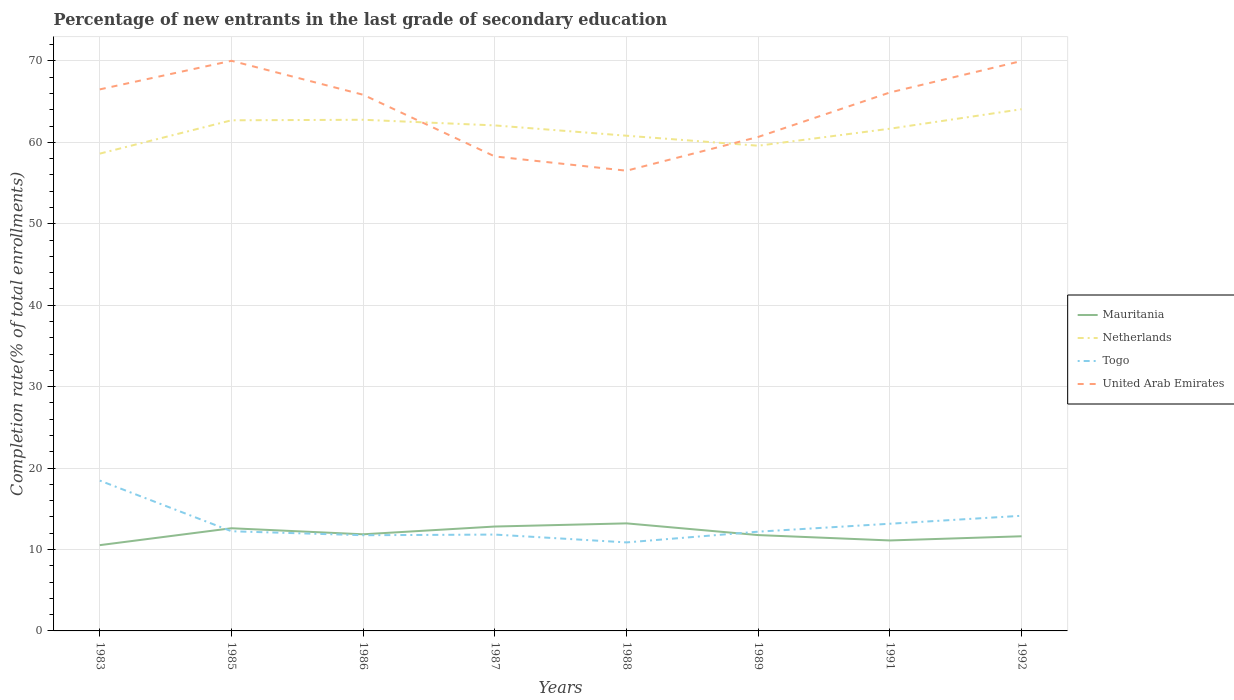Across all years, what is the maximum percentage of new entrants in Togo?
Provide a short and direct response. 10.87. What is the total percentage of new entrants in Netherlands in the graph?
Your answer should be compact. 3.19. What is the difference between the highest and the second highest percentage of new entrants in Netherlands?
Offer a terse response. 5.45. Is the percentage of new entrants in United Arab Emirates strictly greater than the percentage of new entrants in Togo over the years?
Ensure brevity in your answer.  No. Are the values on the major ticks of Y-axis written in scientific E-notation?
Your response must be concise. No. Does the graph contain any zero values?
Your answer should be very brief. No. Where does the legend appear in the graph?
Your answer should be compact. Center right. What is the title of the graph?
Provide a succinct answer. Percentage of new entrants in the last grade of secondary education. What is the label or title of the Y-axis?
Ensure brevity in your answer.  Completion rate(% of total enrollments). What is the Completion rate(% of total enrollments) in Mauritania in 1983?
Provide a short and direct response. 10.53. What is the Completion rate(% of total enrollments) in Netherlands in 1983?
Your response must be concise. 58.61. What is the Completion rate(% of total enrollments) in Togo in 1983?
Your answer should be compact. 18.46. What is the Completion rate(% of total enrollments) of United Arab Emirates in 1983?
Provide a short and direct response. 66.5. What is the Completion rate(% of total enrollments) of Mauritania in 1985?
Offer a very short reply. 12.61. What is the Completion rate(% of total enrollments) of Netherlands in 1985?
Provide a succinct answer. 62.7. What is the Completion rate(% of total enrollments) of Togo in 1985?
Offer a very short reply. 12.24. What is the Completion rate(% of total enrollments) in United Arab Emirates in 1985?
Give a very brief answer. 70.01. What is the Completion rate(% of total enrollments) in Mauritania in 1986?
Make the answer very short. 11.87. What is the Completion rate(% of total enrollments) of Netherlands in 1986?
Keep it short and to the point. 62.77. What is the Completion rate(% of total enrollments) in Togo in 1986?
Your answer should be very brief. 11.75. What is the Completion rate(% of total enrollments) in United Arab Emirates in 1986?
Provide a short and direct response. 65.84. What is the Completion rate(% of total enrollments) of Mauritania in 1987?
Give a very brief answer. 12.82. What is the Completion rate(% of total enrollments) in Netherlands in 1987?
Your answer should be very brief. 62.07. What is the Completion rate(% of total enrollments) in Togo in 1987?
Provide a succinct answer. 11.83. What is the Completion rate(% of total enrollments) of United Arab Emirates in 1987?
Your answer should be compact. 58.26. What is the Completion rate(% of total enrollments) in Mauritania in 1988?
Make the answer very short. 13.21. What is the Completion rate(% of total enrollments) of Netherlands in 1988?
Provide a succinct answer. 60.81. What is the Completion rate(% of total enrollments) of Togo in 1988?
Your answer should be compact. 10.87. What is the Completion rate(% of total enrollments) in United Arab Emirates in 1988?
Ensure brevity in your answer.  56.51. What is the Completion rate(% of total enrollments) in Mauritania in 1989?
Offer a very short reply. 11.77. What is the Completion rate(% of total enrollments) of Netherlands in 1989?
Ensure brevity in your answer.  59.58. What is the Completion rate(% of total enrollments) in Togo in 1989?
Offer a terse response. 12.19. What is the Completion rate(% of total enrollments) in United Arab Emirates in 1989?
Provide a succinct answer. 60.66. What is the Completion rate(% of total enrollments) in Mauritania in 1991?
Your answer should be very brief. 11.11. What is the Completion rate(% of total enrollments) of Netherlands in 1991?
Keep it short and to the point. 61.67. What is the Completion rate(% of total enrollments) of Togo in 1991?
Make the answer very short. 13.16. What is the Completion rate(% of total enrollments) in United Arab Emirates in 1991?
Offer a very short reply. 66.12. What is the Completion rate(% of total enrollments) in Mauritania in 1992?
Provide a succinct answer. 11.62. What is the Completion rate(% of total enrollments) of Netherlands in 1992?
Offer a very short reply. 64.06. What is the Completion rate(% of total enrollments) of Togo in 1992?
Offer a very short reply. 14.14. What is the Completion rate(% of total enrollments) in United Arab Emirates in 1992?
Ensure brevity in your answer.  69.99. Across all years, what is the maximum Completion rate(% of total enrollments) of Mauritania?
Provide a short and direct response. 13.21. Across all years, what is the maximum Completion rate(% of total enrollments) of Netherlands?
Provide a short and direct response. 64.06. Across all years, what is the maximum Completion rate(% of total enrollments) of Togo?
Your answer should be compact. 18.46. Across all years, what is the maximum Completion rate(% of total enrollments) of United Arab Emirates?
Your response must be concise. 70.01. Across all years, what is the minimum Completion rate(% of total enrollments) of Mauritania?
Make the answer very short. 10.53. Across all years, what is the minimum Completion rate(% of total enrollments) in Netherlands?
Your answer should be very brief. 58.61. Across all years, what is the minimum Completion rate(% of total enrollments) of Togo?
Your answer should be compact. 10.87. Across all years, what is the minimum Completion rate(% of total enrollments) in United Arab Emirates?
Provide a short and direct response. 56.51. What is the total Completion rate(% of total enrollments) in Mauritania in the graph?
Give a very brief answer. 95.53. What is the total Completion rate(% of total enrollments) of Netherlands in the graph?
Provide a succinct answer. 492.28. What is the total Completion rate(% of total enrollments) in Togo in the graph?
Offer a terse response. 104.64. What is the total Completion rate(% of total enrollments) in United Arab Emirates in the graph?
Offer a terse response. 513.89. What is the difference between the Completion rate(% of total enrollments) of Mauritania in 1983 and that in 1985?
Offer a very short reply. -2.08. What is the difference between the Completion rate(% of total enrollments) of Netherlands in 1983 and that in 1985?
Offer a terse response. -4.09. What is the difference between the Completion rate(% of total enrollments) in Togo in 1983 and that in 1985?
Your answer should be very brief. 6.22. What is the difference between the Completion rate(% of total enrollments) in United Arab Emirates in 1983 and that in 1985?
Your answer should be very brief. -3.51. What is the difference between the Completion rate(% of total enrollments) in Mauritania in 1983 and that in 1986?
Your answer should be compact. -1.33. What is the difference between the Completion rate(% of total enrollments) in Netherlands in 1983 and that in 1986?
Provide a short and direct response. -4.16. What is the difference between the Completion rate(% of total enrollments) in Togo in 1983 and that in 1986?
Give a very brief answer. 6.71. What is the difference between the Completion rate(% of total enrollments) in United Arab Emirates in 1983 and that in 1986?
Your response must be concise. 0.66. What is the difference between the Completion rate(% of total enrollments) of Mauritania in 1983 and that in 1987?
Your answer should be compact. -2.29. What is the difference between the Completion rate(% of total enrollments) in Netherlands in 1983 and that in 1987?
Provide a short and direct response. -3.46. What is the difference between the Completion rate(% of total enrollments) of Togo in 1983 and that in 1987?
Give a very brief answer. 6.63. What is the difference between the Completion rate(% of total enrollments) of United Arab Emirates in 1983 and that in 1987?
Your answer should be compact. 8.24. What is the difference between the Completion rate(% of total enrollments) in Mauritania in 1983 and that in 1988?
Your answer should be compact. -2.68. What is the difference between the Completion rate(% of total enrollments) of Netherlands in 1983 and that in 1988?
Provide a short and direct response. -2.2. What is the difference between the Completion rate(% of total enrollments) of Togo in 1983 and that in 1988?
Provide a succinct answer. 7.59. What is the difference between the Completion rate(% of total enrollments) in United Arab Emirates in 1983 and that in 1988?
Ensure brevity in your answer.  9.99. What is the difference between the Completion rate(% of total enrollments) of Mauritania in 1983 and that in 1989?
Keep it short and to the point. -1.24. What is the difference between the Completion rate(% of total enrollments) in Netherlands in 1983 and that in 1989?
Ensure brevity in your answer.  -0.97. What is the difference between the Completion rate(% of total enrollments) in Togo in 1983 and that in 1989?
Give a very brief answer. 6.27. What is the difference between the Completion rate(% of total enrollments) in United Arab Emirates in 1983 and that in 1989?
Your answer should be very brief. 5.84. What is the difference between the Completion rate(% of total enrollments) of Mauritania in 1983 and that in 1991?
Your answer should be compact. -0.58. What is the difference between the Completion rate(% of total enrollments) in Netherlands in 1983 and that in 1991?
Provide a succinct answer. -3.06. What is the difference between the Completion rate(% of total enrollments) in Togo in 1983 and that in 1991?
Provide a succinct answer. 5.3. What is the difference between the Completion rate(% of total enrollments) in United Arab Emirates in 1983 and that in 1991?
Your answer should be very brief. 0.38. What is the difference between the Completion rate(% of total enrollments) in Mauritania in 1983 and that in 1992?
Keep it short and to the point. -1.09. What is the difference between the Completion rate(% of total enrollments) of Netherlands in 1983 and that in 1992?
Offer a very short reply. -5.45. What is the difference between the Completion rate(% of total enrollments) of Togo in 1983 and that in 1992?
Give a very brief answer. 4.32. What is the difference between the Completion rate(% of total enrollments) in United Arab Emirates in 1983 and that in 1992?
Keep it short and to the point. -3.49. What is the difference between the Completion rate(% of total enrollments) in Mauritania in 1985 and that in 1986?
Give a very brief answer. 0.74. What is the difference between the Completion rate(% of total enrollments) in Netherlands in 1985 and that in 1986?
Offer a terse response. -0.07. What is the difference between the Completion rate(% of total enrollments) of Togo in 1985 and that in 1986?
Give a very brief answer. 0.49. What is the difference between the Completion rate(% of total enrollments) in United Arab Emirates in 1985 and that in 1986?
Provide a short and direct response. 4.17. What is the difference between the Completion rate(% of total enrollments) of Mauritania in 1985 and that in 1987?
Your response must be concise. -0.21. What is the difference between the Completion rate(% of total enrollments) of Netherlands in 1985 and that in 1987?
Your answer should be very brief. 0.63. What is the difference between the Completion rate(% of total enrollments) of Togo in 1985 and that in 1987?
Give a very brief answer. 0.41. What is the difference between the Completion rate(% of total enrollments) of United Arab Emirates in 1985 and that in 1987?
Give a very brief answer. 11.75. What is the difference between the Completion rate(% of total enrollments) in Mauritania in 1985 and that in 1988?
Your response must be concise. -0.6. What is the difference between the Completion rate(% of total enrollments) of Netherlands in 1985 and that in 1988?
Offer a terse response. 1.89. What is the difference between the Completion rate(% of total enrollments) of Togo in 1985 and that in 1988?
Give a very brief answer. 1.37. What is the difference between the Completion rate(% of total enrollments) of United Arab Emirates in 1985 and that in 1988?
Your answer should be very brief. 13.5. What is the difference between the Completion rate(% of total enrollments) of Mauritania in 1985 and that in 1989?
Provide a short and direct response. 0.84. What is the difference between the Completion rate(% of total enrollments) of Netherlands in 1985 and that in 1989?
Make the answer very short. 3.12. What is the difference between the Completion rate(% of total enrollments) in Togo in 1985 and that in 1989?
Your answer should be compact. 0.05. What is the difference between the Completion rate(% of total enrollments) in United Arab Emirates in 1985 and that in 1989?
Offer a terse response. 9.35. What is the difference between the Completion rate(% of total enrollments) in Mauritania in 1985 and that in 1991?
Give a very brief answer. 1.5. What is the difference between the Completion rate(% of total enrollments) in Netherlands in 1985 and that in 1991?
Offer a very short reply. 1.03. What is the difference between the Completion rate(% of total enrollments) in Togo in 1985 and that in 1991?
Provide a succinct answer. -0.92. What is the difference between the Completion rate(% of total enrollments) in United Arab Emirates in 1985 and that in 1991?
Offer a terse response. 3.89. What is the difference between the Completion rate(% of total enrollments) in Mauritania in 1985 and that in 1992?
Keep it short and to the point. 0.99. What is the difference between the Completion rate(% of total enrollments) in Netherlands in 1985 and that in 1992?
Your answer should be very brief. -1.36. What is the difference between the Completion rate(% of total enrollments) of Togo in 1985 and that in 1992?
Your answer should be compact. -1.9. What is the difference between the Completion rate(% of total enrollments) of United Arab Emirates in 1985 and that in 1992?
Give a very brief answer. 0.02. What is the difference between the Completion rate(% of total enrollments) of Mauritania in 1986 and that in 1987?
Your answer should be very brief. -0.95. What is the difference between the Completion rate(% of total enrollments) in Netherlands in 1986 and that in 1987?
Ensure brevity in your answer.  0.69. What is the difference between the Completion rate(% of total enrollments) of Togo in 1986 and that in 1987?
Your answer should be compact. -0.08. What is the difference between the Completion rate(% of total enrollments) in United Arab Emirates in 1986 and that in 1987?
Provide a succinct answer. 7.58. What is the difference between the Completion rate(% of total enrollments) in Mauritania in 1986 and that in 1988?
Provide a short and direct response. -1.34. What is the difference between the Completion rate(% of total enrollments) of Netherlands in 1986 and that in 1988?
Provide a succinct answer. 1.96. What is the difference between the Completion rate(% of total enrollments) of Togo in 1986 and that in 1988?
Offer a very short reply. 0.88. What is the difference between the Completion rate(% of total enrollments) in United Arab Emirates in 1986 and that in 1988?
Your response must be concise. 9.33. What is the difference between the Completion rate(% of total enrollments) in Mauritania in 1986 and that in 1989?
Your answer should be very brief. 0.1. What is the difference between the Completion rate(% of total enrollments) of Netherlands in 1986 and that in 1989?
Your response must be concise. 3.19. What is the difference between the Completion rate(% of total enrollments) in Togo in 1986 and that in 1989?
Your answer should be very brief. -0.44. What is the difference between the Completion rate(% of total enrollments) of United Arab Emirates in 1986 and that in 1989?
Provide a short and direct response. 5.18. What is the difference between the Completion rate(% of total enrollments) in Mauritania in 1986 and that in 1991?
Offer a very short reply. 0.76. What is the difference between the Completion rate(% of total enrollments) in Netherlands in 1986 and that in 1991?
Your answer should be compact. 1.1. What is the difference between the Completion rate(% of total enrollments) of Togo in 1986 and that in 1991?
Offer a very short reply. -1.41. What is the difference between the Completion rate(% of total enrollments) in United Arab Emirates in 1986 and that in 1991?
Your answer should be compact. -0.28. What is the difference between the Completion rate(% of total enrollments) of Mauritania in 1986 and that in 1992?
Your answer should be very brief. 0.24. What is the difference between the Completion rate(% of total enrollments) in Netherlands in 1986 and that in 1992?
Keep it short and to the point. -1.3. What is the difference between the Completion rate(% of total enrollments) of Togo in 1986 and that in 1992?
Make the answer very short. -2.39. What is the difference between the Completion rate(% of total enrollments) in United Arab Emirates in 1986 and that in 1992?
Make the answer very short. -4.15. What is the difference between the Completion rate(% of total enrollments) in Mauritania in 1987 and that in 1988?
Provide a succinct answer. -0.39. What is the difference between the Completion rate(% of total enrollments) in Netherlands in 1987 and that in 1988?
Your answer should be very brief. 1.26. What is the difference between the Completion rate(% of total enrollments) of Togo in 1987 and that in 1988?
Your response must be concise. 0.96. What is the difference between the Completion rate(% of total enrollments) in United Arab Emirates in 1987 and that in 1988?
Offer a very short reply. 1.75. What is the difference between the Completion rate(% of total enrollments) of Mauritania in 1987 and that in 1989?
Provide a succinct answer. 1.05. What is the difference between the Completion rate(% of total enrollments) in Netherlands in 1987 and that in 1989?
Give a very brief answer. 2.49. What is the difference between the Completion rate(% of total enrollments) in Togo in 1987 and that in 1989?
Your response must be concise. -0.36. What is the difference between the Completion rate(% of total enrollments) in United Arab Emirates in 1987 and that in 1989?
Your response must be concise. -2.4. What is the difference between the Completion rate(% of total enrollments) of Mauritania in 1987 and that in 1991?
Your answer should be compact. 1.71. What is the difference between the Completion rate(% of total enrollments) in Netherlands in 1987 and that in 1991?
Your answer should be compact. 0.4. What is the difference between the Completion rate(% of total enrollments) of Togo in 1987 and that in 1991?
Keep it short and to the point. -1.33. What is the difference between the Completion rate(% of total enrollments) of United Arab Emirates in 1987 and that in 1991?
Keep it short and to the point. -7.86. What is the difference between the Completion rate(% of total enrollments) of Mauritania in 1987 and that in 1992?
Make the answer very short. 1.2. What is the difference between the Completion rate(% of total enrollments) in Netherlands in 1987 and that in 1992?
Offer a very short reply. -1.99. What is the difference between the Completion rate(% of total enrollments) of Togo in 1987 and that in 1992?
Keep it short and to the point. -2.31. What is the difference between the Completion rate(% of total enrollments) in United Arab Emirates in 1987 and that in 1992?
Provide a succinct answer. -11.72. What is the difference between the Completion rate(% of total enrollments) in Mauritania in 1988 and that in 1989?
Make the answer very short. 1.44. What is the difference between the Completion rate(% of total enrollments) in Netherlands in 1988 and that in 1989?
Make the answer very short. 1.23. What is the difference between the Completion rate(% of total enrollments) in Togo in 1988 and that in 1989?
Your response must be concise. -1.32. What is the difference between the Completion rate(% of total enrollments) in United Arab Emirates in 1988 and that in 1989?
Provide a short and direct response. -4.15. What is the difference between the Completion rate(% of total enrollments) of Mauritania in 1988 and that in 1991?
Make the answer very short. 2.1. What is the difference between the Completion rate(% of total enrollments) in Netherlands in 1988 and that in 1991?
Your answer should be compact. -0.86. What is the difference between the Completion rate(% of total enrollments) of Togo in 1988 and that in 1991?
Ensure brevity in your answer.  -2.29. What is the difference between the Completion rate(% of total enrollments) in United Arab Emirates in 1988 and that in 1991?
Provide a succinct answer. -9.61. What is the difference between the Completion rate(% of total enrollments) of Mauritania in 1988 and that in 1992?
Keep it short and to the point. 1.58. What is the difference between the Completion rate(% of total enrollments) of Netherlands in 1988 and that in 1992?
Offer a terse response. -3.25. What is the difference between the Completion rate(% of total enrollments) in Togo in 1988 and that in 1992?
Offer a very short reply. -3.27. What is the difference between the Completion rate(% of total enrollments) of United Arab Emirates in 1988 and that in 1992?
Provide a short and direct response. -13.47. What is the difference between the Completion rate(% of total enrollments) in Mauritania in 1989 and that in 1991?
Your answer should be very brief. 0.66. What is the difference between the Completion rate(% of total enrollments) in Netherlands in 1989 and that in 1991?
Make the answer very short. -2.09. What is the difference between the Completion rate(% of total enrollments) in Togo in 1989 and that in 1991?
Your answer should be compact. -0.97. What is the difference between the Completion rate(% of total enrollments) in United Arab Emirates in 1989 and that in 1991?
Make the answer very short. -5.46. What is the difference between the Completion rate(% of total enrollments) of Mauritania in 1989 and that in 1992?
Offer a terse response. 0.15. What is the difference between the Completion rate(% of total enrollments) in Netherlands in 1989 and that in 1992?
Your answer should be very brief. -4.48. What is the difference between the Completion rate(% of total enrollments) in Togo in 1989 and that in 1992?
Offer a very short reply. -1.95. What is the difference between the Completion rate(% of total enrollments) in United Arab Emirates in 1989 and that in 1992?
Your answer should be compact. -9.33. What is the difference between the Completion rate(% of total enrollments) of Mauritania in 1991 and that in 1992?
Offer a terse response. -0.51. What is the difference between the Completion rate(% of total enrollments) in Netherlands in 1991 and that in 1992?
Ensure brevity in your answer.  -2.39. What is the difference between the Completion rate(% of total enrollments) in Togo in 1991 and that in 1992?
Provide a short and direct response. -0.98. What is the difference between the Completion rate(% of total enrollments) of United Arab Emirates in 1991 and that in 1992?
Your answer should be very brief. -3.87. What is the difference between the Completion rate(% of total enrollments) of Mauritania in 1983 and the Completion rate(% of total enrollments) of Netherlands in 1985?
Your answer should be very brief. -52.17. What is the difference between the Completion rate(% of total enrollments) of Mauritania in 1983 and the Completion rate(% of total enrollments) of Togo in 1985?
Your answer should be very brief. -1.71. What is the difference between the Completion rate(% of total enrollments) of Mauritania in 1983 and the Completion rate(% of total enrollments) of United Arab Emirates in 1985?
Provide a succinct answer. -59.48. What is the difference between the Completion rate(% of total enrollments) of Netherlands in 1983 and the Completion rate(% of total enrollments) of Togo in 1985?
Make the answer very short. 46.37. What is the difference between the Completion rate(% of total enrollments) of Netherlands in 1983 and the Completion rate(% of total enrollments) of United Arab Emirates in 1985?
Your answer should be compact. -11.4. What is the difference between the Completion rate(% of total enrollments) in Togo in 1983 and the Completion rate(% of total enrollments) in United Arab Emirates in 1985?
Your response must be concise. -51.55. What is the difference between the Completion rate(% of total enrollments) in Mauritania in 1983 and the Completion rate(% of total enrollments) in Netherlands in 1986?
Offer a very short reply. -52.24. What is the difference between the Completion rate(% of total enrollments) in Mauritania in 1983 and the Completion rate(% of total enrollments) in Togo in 1986?
Ensure brevity in your answer.  -1.22. What is the difference between the Completion rate(% of total enrollments) of Mauritania in 1983 and the Completion rate(% of total enrollments) of United Arab Emirates in 1986?
Provide a succinct answer. -55.31. What is the difference between the Completion rate(% of total enrollments) in Netherlands in 1983 and the Completion rate(% of total enrollments) in Togo in 1986?
Offer a very short reply. 46.86. What is the difference between the Completion rate(% of total enrollments) in Netherlands in 1983 and the Completion rate(% of total enrollments) in United Arab Emirates in 1986?
Provide a succinct answer. -7.23. What is the difference between the Completion rate(% of total enrollments) in Togo in 1983 and the Completion rate(% of total enrollments) in United Arab Emirates in 1986?
Offer a very short reply. -47.38. What is the difference between the Completion rate(% of total enrollments) in Mauritania in 1983 and the Completion rate(% of total enrollments) in Netherlands in 1987?
Provide a succinct answer. -51.54. What is the difference between the Completion rate(% of total enrollments) in Mauritania in 1983 and the Completion rate(% of total enrollments) in Togo in 1987?
Offer a very short reply. -1.3. What is the difference between the Completion rate(% of total enrollments) of Mauritania in 1983 and the Completion rate(% of total enrollments) of United Arab Emirates in 1987?
Offer a very short reply. -47.73. What is the difference between the Completion rate(% of total enrollments) of Netherlands in 1983 and the Completion rate(% of total enrollments) of Togo in 1987?
Your response must be concise. 46.78. What is the difference between the Completion rate(% of total enrollments) in Netherlands in 1983 and the Completion rate(% of total enrollments) in United Arab Emirates in 1987?
Your answer should be compact. 0.35. What is the difference between the Completion rate(% of total enrollments) of Togo in 1983 and the Completion rate(% of total enrollments) of United Arab Emirates in 1987?
Your response must be concise. -39.8. What is the difference between the Completion rate(% of total enrollments) of Mauritania in 1983 and the Completion rate(% of total enrollments) of Netherlands in 1988?
Make the answer very short. -50.28. What is the difference between the Completion rate(% of total enrollments) of Mauritania in 1983 and the Completion rate(% of total enrollments) of Togo in 1988?
Your answer should be very brief. -0.34. What is the difference between the Completion rate(% of total enrollments) in Mauritania in 1983 and the Completion rate(% of total enrollments) in United Arab Emirates in 1988?
Make the answer very short. -45.98. What is the difference between the Completion rate(% of total enrollments) in Netherlands in 1983 and the Completion rate(% of total enrollments) in Togo in 1988?
Provide a succinct answer. 47.74. What is the difference between the Completion rate(% of total enrollments) in Netherlands in 1983 and the Completion rate(% of total enrollments) in United Arab Emirates in 1988?
Give a very brief answer. 2.1. What is the difference between the Completion rate(% of total enrollments) of Togo in 1983 and the Completion rate(% of total enrollments) of United Arab Emirates in 1988?
Your response must be concise. -38.05. What is the difference between the Completion rate(% of total enrollments) of Mauritania in 1983 and the Completion rate(% of total enrollments) of Netherlands in 1989?
Your answer should be compact. -49.05. What is the difference between the Completion rate(% of total enrollments) in Mauritania in 1983 and the Completion rate(% of total enrollments) in Togo in 1989?
Give a very brief answer. -1.66. What is the difference between the Completion rate(% of total enrollments) in Mauritania in 1983 and the Completion rate(% of total enrollments) in United Arab Emirates in 1989?
Make the answer very short. -50.13. What is the difference between the Completion rate(% of total enrollments) of Netherlands in 1983 and the Completion rate(% of total enrollments) of Togo in 1989?
Offer a terse response. 46.42. What is the difference between the Completion rate(% of total enrollments) in Netherlands in 1983 and the Completion rate(% of total enrollments) in United Arab Emirates in 1989?
Your response must be concise. -2.05. What is the difference between the Completion rate(% of total enrollments) of Togo in 1983 and the Completion rate(% of total enrollments) of United Arab Emirates in 1989?
Ensure brevity in your answer.  -42.2. What is the difference between the Completion rate(% of total enrollments) in Mauritania in 1983 and the Completion rate(% of total enrollments) in Netherlands in 1991?
Your answer should be very brief. -51.14. What is the difference between the Completion rate(% of total enrollments) of Mauritania in 1983 and the Completion rate(% of total enrollments) of Togo in 1991?
Offer a very short reply. -2.63. What is the difference between the Completion rate(% of total enrollments) of Mauritania in 1983 and the Completion rate(% of total enrollments) of United Arab Emirates in 1991?
Offer a very short reply. -55.59. What is the difference between the Completion rate(% of total enrollments) in Netherlands in 1983 and the Completion rate(% of total enrollments) in Togo in 1991?
Your answer should be very brief. 45.45. What is the difference between the Completion rate(% of total enrollments) in Netherlands in 1983 and the Completion rate(% of total enrollments) in United Arab Emirates in 1991?
Provide a succinct answer. -7.51. What is the difference between the Completion rate(% of total enrollments) of Togo in 1983 and the Completion rate(% of total enrollments) of United Arab Emirates in 1991?
Your response must be concise. -47.66. What is the difference between the Completion rate(% of total enrollments) in Mauritania in 1983 and the Completion rate(% of total enrollments) in Netherlands in 1992?
Your answer should be compact. -53.53. What is the difference between the Completion rate(% of total enrollments) in Mauritania in 1983 and the Completion rate(% of total enrollments) in Togo in 1992?
Your response must be concise. -3.61. What is the difference between the Completion rate(% of total enrollments) in Mauritania in 1983 and the Completion rate(% of total enrollments) in United Arab Emirates in 1992?
Provide a succinct answer. -59.45. What is the difference between the Completion rate(% of total enrollments) in Netherlands in 1983 and the Completion rate(% of total enrollments) in Togo in 1992?
Ensure brevity in your answer.  44.47. What is the difference between the Completion rate(% of total enrollments) of Netherlands in 1983 and the Completion rate(% of total enrollments) of United Arab Emirates in 1992?
Your answer should be compact. -11.38. What is the difference between the Completion rate(% of total enrollments) of Togo in 1983 and the Completion rate(% of total enrollments) of United Arab Emirates in 1992?
Your answer should be compact. -51.53. What is the difference between the Completion rate(% of total enrollments) of Mauritania in 1985 and the Completion rate(% of total enrollments) of Netherlands in 1986?
Give a very brief answer. -50.16. What is the difference between the Completion rate(% of total enrollments) of Mauritania in 1985 and the Completion rate(% of total enrollments) of Togo in 1986?
Make the answer very short. 0.86. What is the difference between the Completion rate(% of total enrollments) in Mauritania in 1985 and the Completion rate(% of total enrollments) in United Arab Emirates in 1986?
Your answer should be compact. -53.23. What is the difference between the Completion rate(% of total enrollments) in Netherlands in 1985 and the Completion rate(% of total enrollments) in Togo in 1986?
Your response must be concise. 50.95. What is the difference between the Completion rate(% of total enrollments) in Netherlands in 1985 and the Completion rate(% of total enrollments) in United Arab Emirates in 1986?
Offer a terse response. -3.14. What is the difference between the Completion rate(% of total enrollments) of Togo in 1985 and the Completion rate(% of total enrollments) of United Arab Emirates in 1986?
Keep it short and to the point. -53.6. What is the difference between the Completion rate(% of total enrollments) in Mauritania in 1985 and the Completion rate(% of total enrollments) in Netherlands in 1987?
Your response must be concise. -49.47. What is the difference between the Completion rate(% of total enrollments) in Mauritania in 1985 and the Completion rate(% of total enrollments) in Togo in 1987?
Make the answer very short. 0.78. What is the difference between the Completion rate(% of total enrollments) in Mauritania in 1985 and the Completion rate(% of total enrollments) in United Arab Emirates in 1987?
Your answer should be very brief. -45.65. What is the difference between the Completion rate(% of total enrollments) of Netherlands in 1985 and the Completion rate(% of total enrollments) of Togo in 1987?
Make the answer very short. 50.87. What is the difference between the Completion rate(% of total enrollments) in Netherlands in 1985 and the Completion rate(% of total enrollments) in United Arab Emirates in 1987?
Keep it short and to the point. 4.44. What is the difference between the Completion rate(% of total enrollments) in Togo in 1985 and the Completion rate(% of total enrollments) in United Arab Emirates in 1987?
Make the answer very short. -46.02. What is the difference between the Completion rate(% of total enrollments) of Mauritania in 1985 and the Completion rate(% of total enrollments) of Netherlands in 1988?
Keep it short and to the point. -48.2. What is the difference between the Completion rate(% of total enrollments) in Mauritania in 1985 and the Completion rate(% of total enrollments) in Togo in 1988?
Give a very brief answer. 1.74. What is the difference between the Completion rate(% of total enrollments) of Mauritania in 1985 and the Completion rate(% of total enrollments) of United Arab Emirates in 1988?
Your response must be concise. -43.91. What is the difference between the Completion rate(% of total enrollments) of Netherlands in 1985 and the Completion rate(% of total enrollments) of Togo in 1988?
Provide a succinct answer. 51.83. What is the difference between the Completion rate(% of total enrollments) in Netherlands in 1985 and the Completion rate(% of total enrollments) in United Arab Emirates in 1988?
Provide a succinct answer. 6.19. What is the difference between the Completion rate(% of total enrollments) of Togo in 1985 and the Completion rate(% of total enrollments) of United Arab Emirates in 1988?
Your answer should be very brief. -44.27. What is the difference between the Completion rate(% of total enrollments) in Mauritania in 1985 and the Completion rate(% of total enrollments) in Netherlands in 1989?
Ensure brevity in your answer.  -46.97. What is the difference between the Completion rate(% of total enrollments) in Mauritania in 1985 and the Completion rate(% of total enrollments) in Togo in 1989?
Ensure brevity in your answer.  0.42. What is the difference between the Completion rate(% of total enrollments) in Mauritania in 1985 and the Completion rate(% of total enrollments) in United Arab Emirates in 1989?
Your answer should be compact. -48.05. What is the difference between the Completion rate(% of total enrollments) in Netherlands in 1985 and the Completion rate(% of total enrollments) in Togo in 1989?
Make the answer very short. 50.51. What is the difference between the Completion rate(% of total enrollments) of Netherlands in 1985 and the Completion rate(% of total enrollments) of United Arab Emirates in 1989?
Ensure brevity in your answer.  2.04. What is the difference between the Completion rate(% of total enrollments) in Togo in 1985 and the Completion rate(% of total enrollments) in United Arab Emirates in 1989?
Your answer should be compact. -48.42. What is the difference between the Completion rate(% of total enrollments) in Mauritania in 1985 and the Completion rate(% of total enrollments) in Netherlands in 1991?
Offer a terse response. -49.06. What is the difference between the Completion rate(% of total enrollments) of Mauritania in 1985 and the Completion rate(% of total enrollments) of Togo in 1991?
Give a very brief answer. -0.55. What is the difference between the Completion rate(% of total enrollments) in Mauritania in 1985 and the Completion rate(% of total enrollments) in United Arab Emirates in 1991?
Offer a very short reply. -53.51. What is the difference between the Completion rate(% of total enrollments) of Netherlands in 1985 and the Completion rate(% of total enrollments) of Togo in 1991?
Your answer should be very brief. 49.54. What is the difference between the Completion rate(% of total enrollments) of Netherlands in 1985 and the Completion rate(% of total enrollments) of United Arab Emirates in 1991?
Offer a terse response. -3.42. What is the difference between the Completion rate(% of total enrollments) of Togo in 1985 and the Completion rate(% of total enrollments) of United Arab Emirates in 1991?
Your response must be concise. -53.88. What is the difference between the Completion rate(% of total enrollments) of Mauritania in 1985 and the Completion rate(% of total enrollments) of Netherlands in 1992?
Offer a terse response. -51.46. What is the difference between the Completion rate(% of total enrollments) of Mauritania in 1985 and the Completion rate(% of total enrollments) of Togo in 1992?
Keep it short and to the point. -1.53. What is the difference between the Completion rate(% of total enrollments) of Mauritania in 1985 and the Completion rate(% of total enrollments) of United Arab Emirates in 1992?
Keep it short and to the point. -57.38. What is the difference between the Completion rate(% of total enrollments) of Netherlands in 1985 and the Completion rate(% of total enrollments) of Togo in 1992?
Your response must be concise. 48.56. What is the difference between the Completion rate(% of total enrollments) of Netherlands in 1985 and the Completion rate(% of total enrollments) of United Arab Emirates in 1992?
Your answer should be compact. -7.28. What is the difference between the Completion rate(% of total enrollments) of Togo in 1985 and the Completion rate(% of total enrollments) of United Arab Emirates in 1992?
Make the answer very short. -57.75. What is the difference between the Completion rate(% of total enrollments) of Mauritania in 1986 and the Completion rate(% of total enrollments) of Netherlands in 1987?
Your answer should be very brief. -50.21. What is the difference between the Completion rate(% of total enrollments) in Mauritania in 1986 and the Completion rate(% of total enrollments) in Togo in 1987?
Provide a short and direct response. 0.03. What is the difference between the Completion rate(% of total enrollments) of Mauritania in 1986 and the Completion rate(% of total enrollments) of United Arab Emirates in 1987?
Your answer should be compact. -46.4. What is the difference between the Completion rate(% of total enrollments) in Netherlands in 1986 and the Completion rate(% of total enrollments) in Togo in 1987?
Ensure brevity in your answer.  50.94. What is the difference between the Completion rate(% of total enrollments) in Netherlands in 1986 and the Completion rate(% of total enrollments) in United Arab Emirates in 1987?
Your answer should be compact. 4.51. What is the difference between the Completion rate(% of total enrollments) in Togo in 1986 and the Completion rate(% of total enrollments) in United Arab Emirates in 1987?
Keep it short and to the point. -46.51. What is the difference between the Completion rate(% of total enrollments) in Mauritania in 1986 and the Completion rate(% of total enrollments) in Netherlands in 1988?
Offer a very short reply. -48.94. What is the difference between the Completion rate(% of total enrollments) in Mauritania in 1986 and the Completion rate(% of total enrollments) in Togo in 1988?
Your answer should be compact. 1. What is the difference between the Completion rate(% of total enrollments) in Mauritania in 1986 and the Completion rate(% of total enrollments) in United Arab Emirates in 1988?
Give a very brief answer. -44.65. What is the difference between the Completion rate(% of total enrollments) in Netherlands in 1986 and the Completion rate(% of total enrollments) in Togo in 1988?
Provide a succinct answer. 51.9. What is the difference between the Completion rate(% of total enrollments) in Netherlands in 1986 and the Completion rate(% of total enrollments) in United Arab Emirates in 1988?
Give a very brief answer. 6.25. What is the difference between the Completion rate(% of total enrollments) of Togo in 1986 and the Completion rate(% of total enrollments) of United Arab Emirates in 1988?
Your response must be concise. -44.76. What is the difference between the Completion rate(% of total enrollments) of Mauritania in 1986 and the Completion rate(% of total enrollments) of Netherlands in 1989?
Make the answer very short. -47.71. What is the difference between the Completion rate(% of total enrollments) in Mauritania in 1986 and the Completion rate(% of total enrollments) in Togo in 1989?
Offer a terse response. -0.32. What is the difference between the Completion rate(% of total enrollments) of Mauritania in 1986 and the Completion rate(% of total enrollments) of United Arab Emirates in 1989?
Keep it short and to the point. -48.79. What is the difference between the Completion rate(% of total enrollments) in Netherlands in 1986 and the Completion rate(% of total enrollments) in Togo in 1989?
Your answer should be very brief. 50.58. What is the difference between the Completion rate(% of total enrollments) of Netherlands in 1986 and the Completion rate(% of total enrollments) of United Arab Emirates in 1989?
Your answer should be very brief. 2.11. What is the difference between the Completion rate(% of total enrollments) of Togo in 1986 and the Completion rate(% of total enrollments) of United Arab Emirates in 1989?
Ensure brevity in your answer.  -48.91. What is the difference between the Completion rate(% of total enrollments) in Mauritania in 1986 and the Completion rate(% of total enrollments) in Netherlands in 1991?
Offer a terse response. -49.8. What is the difference between the Completion rate(% of total enrollments) of Mauritania in 1986 and the Completion rate(% of total enrollments) of Togo in 1991?
Give a very brief answer. -1.3. What is the difference between the Completion rate(% of total enrollments) of Mauritania in 1986 and the Completion rate(% of total enrollments) of United Arab Emirates in 1991?
Give a very brief answer. -54.25. What is the difference between the Completion rate(% of total enrollments) of Netherlands in 1986 and the Completion rate(% of total enrollments) of Togo in 1991?
Offer a terse response. 49.61. What is the difference between the Completion rate(% of total enrollments) in Netherlands in 1986 and the Completion rate(% of total enrollments) in United Arab Emirates in 1991?
Your answer should be very brief. -3.35. What is the difference between the Completion rate(% of total enrollments) of Togo in 1986 and the Completion rate(% of total enrollments) of United Arab Emirates in 1991?
Your answer should be very brief. -54.37. What is the difference between the Completion rate(% of total enrollments) in Mauritania in 1986 and the Completion rate(% of total enrollments) in Netherlands in 1992?
Your answer should be very brief. -52.2. What is the difference between the Completion rate(% of total enrollments) of Mauritania in 1986 and the Completion rate(% of total enrollments) of Togo in 1992?
Make the answer very short. -2.27. What is the difference between the Completion rate(% of total enrollments) in Mauritania in 1986 and the Completion rate(% of total enrollments) in United Arab Emirates in 1992?
Offer a very short reply. -58.12. What is the difference between the Completion rate(% of total enrollments) in Netherlands in 1986 and the Completion rate(% of total enrollments) in Togo in 1992?
Provide a short and direct response. 48.63. What is the difference between the Completion rate(% of total enrollments) of Netherlands in 1986 and the Completion rate(% of total enrollments) of United Arab Emirates in 1992?
Offer a terse response. -7.22. What is the difference between the Completion rate(% of total enrollments) of Togo in 1986 and the Completion rate(% of total enrollments) of United Arab Emirates in 1992?
Provide a succinct answer. -58.24. What is the difference between the Completion rate(% of total enrollments) of Mauritania in 1987 and the Completion rate(% of total enrollments) of Netherlands in 1988?
Provide a short and direct response. -47.99. What is the difference between the Completion rate(% of total enrollments) in Mauritania in 1987 and the Completion rate(% of total enrollments) in Togo in 1988?
Ensure brevity in your answer.  1.95. What is the difference between the Completion rate(% of total enrollments) in Mauritania in 1987 and the Completion rate(% of total enrollments) in United Arab Emirates in 1988?
Your response must be concise. -43.69. What is the difference between the Completion rate(% of total enrollments) in Netherlands in 1987 and the Completion rate(% of total enrollments) in Togo in 1988?
Ensure brevity in your answer.  51.21. What is the difference between the Completion rate(% of total enrollments) of Netherlands in 1987 and the Completion rate(% of total enrollments) of United Arab Emirates in 1988?
Provide a short and direct response. 5.56. What is the difference between the Completion rate(% of total enrollments) in Togo in 1987 and the Completion rate(% of total enrollments) in United Arab Emirates in 1988?
Offer a very short reply. -44.68. What is the difference between the Completion rate(% of total enrollments) in Mauritania in 1987 and the Completion rate(% of total enrollments) in Netherlands in 1989?
Give a very brief answer. -46.76. What is the difference between the Completion rate(% of total enrollments) in Mauritania in 1987 and the Completion rate(% of total enrollments) in Togo in 1989?
Your answer should be very brief. 0.63. What is the difference between the Completion rate(% of total enrollments) in Mauritania in 1987 and the Completion rate(% of total enrollments) in United Arab Emirates in 1989?
Offer a terse response. -47.84. What is the difference between the Completion rate(% of total enrollments) in Netherlands in 1987 and the Completion rate(% of total enrollments) in Togo in 1989?
Your answer should be very brief. 49.89. What is the difference between the Completion rate(% of total enrollments) of Netherlands in 1987 and the Completion rate(% of total enrollments) of United Arab Emirates in 1989?
Provide a short and direct response. 1.41. What is the difference between the Completion rate(% of total enrollments) in Togo in 1987 and the Completion rate(% of total enrollments) in United Arab Emirates in 1989?
Provide a short and direct response. -48.83. What is the difference between the Completion rate(% of total enrollments) in Mauritania in 1987 and the Completion rate(% of total enrollments) in Netherlands in 1991?
Your response must be concise. -48.85. What is the difference between the Completion rate(% of total enrollments) of Mauritania in 1987 and the Completion rate(% of total enrollments) of Togo in 1991?
Provide a short and direct response. -0.34. What is the difference between the Completion rate(% of total enrollments) of Mauritania in 1987 and the Completion rate(% of total enrollments) of United Arab Emirates in 1991?
Provide a succinct answer. -53.3. What is the difference between the Completion rate(% of total enrollments) in Netherlands in 1987 and the Completion rate(% of total enrollments) in Togo in 1991?
Give a very brief answer. 48.91. What is the difference between the Completion rate(% of total enrollments) of Netherlands in 1987 and the Completion rate(% of total enrollments) of United Arab Emirates in 1991?
Make the answer very short. -4.05. What is the difference between the Completion rate(% of total enrollments) of Togo in 1987 and the Completion rate(% of total enrollments) of United Arab Emirates in 1991?
Give a very brief answer. -54.29. What is the difference between the Completion rate(% of total enrollments) in Mauritania in 1987 and the Completion rate(% of total enrollments) in Netherlands in 1992?
Keep it short and to the point. -51.24. What is the difference between the Completion rate(% of total enrollments) of Mauritania in 1987 and the Completion rate(% of total enrollments) of Togo in 1992?
Your answer should be compact. -1.32. What is the difference between the Completion rate(% of total enrollments) of Mauritania in 1987 and the Completion rate(% of total enrollments) of United Arab Emirates in 1992?
Offer a very short reply. -57.17. What is the difference between the Completion rate(% of total enrollments) in Netherlands in 1987 and the Completion rate(% of total enrollments) in Togo in 1992?
Offer a very short reply. 47.93. What is the difference between the Completion rate(% of total enrollments) of Netherlands in 1987 and the Completion rate(% of total enrollments) of United Arab Emirates in 1992?
Offer a very short reply. -7.91. What is the difference between the Completion rate(% of total enrollments) of Togo in 1987 and the Completion rate(% of total enrollments) of United Arab Emirates in 1992?
Offer a very short reply. -58.15. What is the difference between the Completion rate(% of total enrollments) in Mauritania in 1988 and the Completion rate(% of total enrollments) in Netherlands in 1989?
Offer a terse response. -46.37. What is the difference between the Completion rate(% of total enrollments) in Mauritania in 1988 and the Completion rate(% of total enrollments) in Togo in 1989?
Give a very brief answer. 1.02. What is the difference between the Completion rate(% of total enrollments) of Mauritania in 1988 and the Completion rate(% of total enrollments) of United Arab Emirates in 1989?
Your answer should be compact. -47.45. What is the difference between the Completion rate(% of total enrollments) of Netherlands in 1988 and the Completion rate(% of total enrollments) of Togo in 1989?
Give a very brief answer. 48.62. What is the difference between the Completion rate(% of total enrollments) in Netherlands in 1988 and the Completion rate(% of total enrollments) in United Arab Emirates in 1989?
Your answer should be very brief. 0.15. What is the difference between the Completion rate(% of total enrollments) of Togo in 1988 and the Completion rate(% of total enrollments) of United Arab Emirates in 1989?
Offer a very short reply. -49.79. What is the difference between the Completion rate(% of total enrollments) in Mauritania in 1988 and the Completion rate(% of total enrollments) in Netherlands in 1991?
Keep it short and to the point. -48.46. What is the difference between the Completion rate(% of total enrollments) in Mauritania in 1988 and the Completion rate(% of total enrollments) in Togo in 1991?
Offer a very short reply. 0.05. What is the difference between the Completion rate(% of total enrollments) in Mauritania in 1988 and the Completion rate(% of total enrollments) in United Arab Emirates in 1991?
Provide a succinct answer. -52.91. What is the difference between the Completion rate(% of total enrollments) in Netherlands in 1988 and the Completion rate(% of total enrollments) in Togo in 1991?
Keep it short and to the point. 47.65. What is the difference between the Completion rate(% of total enrollments) of Netherlands in 1988 and the Completion rate(% of total enrollments) of United Arab Emirates in 1991?
Your response must be concise. -5.31. What is the difference between the Completion rate(% of total enrollments) of Togo in 1988 and the Completion rate(% of total enrollments) of United Arab Emirates in 1991?
Ensure brevity in your answer.  -55.25. What is the difference between the Completion rate(% of total enrollments) of Mauritania in 1988 and the Completion rate(% of total enrollments) of Netherlands in 1992?
Your response must be concise. -50.86. What is the difference between the Completion rate(% of total enrollments) in Mauritania in 1988 and the Completion rate(% of total enrollments) in Togo in 1992?
Offer a terse response. -0.93. What is the difference between the Completion rate(% of total enrollments) of Mauritania in 1988 and the Completion rate(% of total enrollments) of United Arab Emirates in 1992?
Ensure brevity in your answer.  -56.78. What is the difference between the Completion rate(% of total enrollments) of Netherlands in 1988 and the Completion rate(% of total enrollments) of Togo in 1992?
Your response must be concise. 46.67. What is the difference between the Completion rate(% of total enrollments) of Netherlands in 1988 and the Completion rate(% of total enrollments) of United Arab Emirates in 1992?
Your answer should be very brief. -9.18. What is the difference between the Completion rate(% of total enrollments) of Togo in 1988 and the Completion rate(% of total enrollments) of United Arab Emirates in 1992?
Offer a terse response. -59.12. What is the difference between the Completion rate(% of total enrollments) of Mauritania in 1989 and the Completion rate(% of total enrollments) of Netherlands in 1991?
Give a very brief answer. -49.9. What is the difference between the Completion rate(% of total enrollments) in Mauritania in 1989 and the Completion rate(% of total enrollments) in Togo in 1991?
Your answer should be very brief. -1.39. What is the difference between the Completion rate(% of total enrollments) of Mauritania in 1989 and the Completion rate(% of total enrollments) of United Arab Emirates in 1991?
Your response must be concise. -54.35. What is the difference between the Completion rate(% of total enrollments) of Netherlands in 1989 and the Completion rate(% of total enrollments) of Togo in 1991?
Offer a very short reply. 46.42. What is the difference between the Completion rate(% of total enrollments) of Netherlands in 1989 and the Completion rate(% of total enrollments) of United Arab Emirates in 1991?
Your answer should be very brief. -6.54. What is the difference between the Completion rate(% of total enrollments) in Togo in 1989 and the Completion rate(% of total enrollments) in United Arab Emirates in 1991?
Provide a short and direct response. -53.93. What is the difference between the Completion rate(% of total enrollments) in Mauritania in 1989 and the Completion rate(% of total enrollments) in Netherlands in 1992?
Ensure brevity in your answer.  -52.29. What is the difference between the Completion rate(% of total enrollments) in Mauritania in 1989 and the Completion rate(% of total enrollments) in Togo in 1992?
Provide a succinct answer. -2.37. What is the difference between the Completion rate(% of total enrollments) of Mauritania in 1989 and the Completion rate(% of total enrollments) of United Arab Emirates in 1992?
Offer a very short reply. -58.22. What is the difference between the Completion rate(% of total enrollments) in Netherlands in 1989 and the Completion rate(% of total enrollments) in Togo in 1992?
Keep it short and to the point. 45.44. What is the difference between the Completion rate(% of total enrollments) of Netherlands in 1989 and the Completion rate(% of total enrollments) of United Arab Emirates in 1992?
Your answer should be compact. -10.4. What is the difference between the Completion rate(% of total enrollments) in Togo in 1989 and the Completion rate(% of total enrollments) in United Arab Emirates in 1992?
Keep it short and to the point. -57.8. What is the difference between the Completion rate(% of total enrollments) of Mauritania in 1991 and the Completion rate(% of total enrollments) of Netherlands in 1992?
Give a very brief answer. -52.96. What is the difference between the Completion rate(% of total enrollments) of Mauritania in 1991 and the Completion rate(% of total enrollments) of Togo in 1992?
Keep it short and to the point. -3.03. What is the difference between the Completion rate(% of total enrollments) of Mauritania in 1991 and the Completion rate(% of total enrollments) of United Arab Emirates in 1992?
Offer a very short reply. -58.88. What is the difference between the Completion rate(% of total enrollments) of Netherlands in 1991 and the Completion rate(% of total enrollments) of Togo in 1992?
Your response must be concise. 47.53. What is the difference between the Completion rate(% of total enrollments) of Netherlands in 1991 and the Completion rate(% of total enrollments) of United Arab Emirates in 1992?
Provide a succinct answer. -8.32. What is the difference between the Completion rate(% of total enrollments) of Togo in 1991 and the Completion rate(% of total enrollments) of United Arab Emirates in 1992?
Your response must be concise. -56.82. What is the average Completion rate(% of total enrollments) of Mauritania per year?
Give a very brief answer. 11.94. What is the average Completion rate(% of total enrollments) of Netherlands per year?
Offer a terse response. 61.53. What is the average Completion rate(% of total enrollments) in Togo per year?
Give a very brief answer. 13.08. What is the average Completion rate(% of total enrollments) of United Arab Emirates per year?
Provide a short and direct response. 64.24. In the year 1983, what is the difference between the Completion rate(% of total enrollments) of Mauritania and Completion rate(% of total enrollments) of Netherlands?
Ensure brevity in your answer.  -48.08. In the year 1983, what is the difference between the Completion rate(% of total enrollments) of Mauritania and Completion rate(% of total enrollments) of Togo?
Give a very brief answer. -7.93. In the year 1983, what is the difference between the Completion rate(% of total enrollments) in Mauritania and Completion rate(% of total enrollments) in United Arab Emirates?
Offer a terse response. -55.97. In the year 1983, what is the difference between the Completion rate(% of total enrollments) in Netherlands and Completion rate(% of total enrollments) in Togo?
Offer a terse response. 40.15. In the year 1983, what is the difference between the Completion rate(% of total enrollments) of Netherlands and Completion rate(% of total enrollments) of United Arab Emirates?
Provide a succinct answer. -7.89. In the year 1983, what is the difference between the Completion rate(% of total enrollments) in Togo and Completion rate(% of total enrollments) in United Arab Emirates?
Offer a very short reply. -48.04. In the year 1985, what is the difference between the Completion rate(% of total enrollments) in Mauritania and Completion rate(% of total enrollments) in Netherlands?
Provide a succinct answer. -50.09. In the year 1985, what is the difference between the Completion rate(% of total enrollments) of Mauritania and Completion rate(% of total enrollments) of Togo?
Keep it short and to the point. 0.37. In the year 1985, what is the difference between the Completion rate(% of total enrollments) in Mauritania and Completion rate(% of total enrollments) in United Arab Emirates?
Your answer should be very brief. -57.4. In the year 1985, what is the difference between the Completion rate(% of total enrollments) in Netherlands and Completion rate(% of total enrollments) in Togo?
Make the answer very short. 50.46. In the year 1985, what is the difference between the Completion rate(% of total enrollments) of Netherlands and Completion rate(% of total enrollments) of United Arab Emirates?
Offer a very short reply. -7.31. In the year 1985, what is the difference between the Completion rate(% of total enrollments) of Togo and Completion rate(% of total enrollments) of United Arab Emirates?
Your answer should be compact. -57.77. In the year 1986, what is the difference between the Completion rate(% of total enrollments) in Mauritania and Completion rate(% of total enrollments) in Netherlands?
Provide a succinct answer. -50.9. In the year 1986, what is the difference between the Completion rate(% of total enrollments) in Mauritania and Completion rate(% of total enrollments) in Togo?
Give a very brief answer. 0.12. In the year 1986, what is the difference between the Completion rate(% of total enrollments) of Mauritania and Completion rate(% of total enrollments) of United Arab Emirates?
Make the answer very short. -53.97. In the year 1986, what is the difference between the Completion rate(% of total enrollments) in Netherlands and Completion rate(% of total enrollments) in Togo?
Ensure brevity in your answer.  51.02. In the year 1986, what is the difference between the Completion rate(% of total enrollments) of Netherlands and Completion rate(% of total enrollments) of United Arab Emirates?
Your answer should be compact. -3.07. In the year 1986, what is the difference between the Completion rate(% of total enrollments) of Togo and Completion rate(% of total enrollments) of United Arab Emirates?
Your answer should be compact. -54.09. In the year 1987, what is the difference between the Completion rate(% of total enrollments) in Mauritania and Completion rate(% of total enrollments) in Netherlands?
Your answer should be very brief. -49.25. In the year 1987, what is the difference between the Completion rate(% of total enrollments) of Mauritania and Completion rate(% of total enrollments) of Togo?
Your response must be concise. 0.99. In the year 1987, what is the difference between the Completion rate(% of total enrollments) of Mauritania and Completion rate(% of total enrollments) of United Arab Emirates?
Give a very brief answer. -45.44. In the year 1987, what is the difference between the Completion rate(% of total enrollments) of Netherlands and Completion rate(% of total enrollments) of Togo?
Provide a short and direct response. 50.24. In the year 1987, what is the difference between the Completion rate(% of total enrollments) of Netherlands and Completion rate(% of total enrollments) of United Arab Emirates?
Your response must be concise. 3.81. In the year 1987, what is the difference between the Completion rate(% of total enrollments) of Togo and Completion rate(% of total enrollments) of United Arab Emirates?
Your answer should be compact. -46.43. In the year 1988, what is the difference between the Completion rate(% of total enrollments) in Mauritania and Completion rate(% of total enrollments) in Netherlands?
Keep it short and to the point. -47.6. In the year 1988, what is the difference between the Completion rate(% of total enrollments) of Mauritania and Completion rate(% of total enrollments) of Togo?
Your answer should be compact. 2.34. In the year 1988, what is the difference between the Completion rate(% of total enrollments) in Mauritania and Completion rate(% of total enrollments) in United Arab Emirates?
Provide a short and direct response. -43.31. In the year 1988, what is the difference between the Completion rate(% of total enrollments) of Netherlands and Completion rate(% of total enrollments) of Togo?
Keep it short and to the point. 49.94. In the year 1988, what is the difference between the Completion rate(% of total enrollments) of Netherlands and Completion rate(% of total enrollments) of United Arab Emirates?
Give a very brief answer. 4.3. In the year 1988, what is the difference between the Completion rate(% of total enrollments) in Togo and Completion rate(% of total enrollments) in United Arab Emirates?
Provide a succinct answer. -45.65. In the year 1989, what is the difference between the Completion rate(% of total enrollments) in Mauritania and Completion rate(% of total enrollments) in Netherlands?
Make the answer very short. -47.81. In the year 1989, what is the difference between the Completion rate(% of total enrollments) in Mauritania and Completion rate(% of total enrollments) in Togo?
Your response must be concise. -0.42. In the year 1989, what is the difference between the Completion rate(% of total enrollments) of Mauritania and Completion rate(% of total enrollments) of United Arab Emirates?
Your answer should be very brief. -48.89. In the year 1989, what is the difference between the Completion rate(% of total enrollments) in Netherlands and Completion rate(% of total enrollments) in Togo?
Your answer should be very brief. 47.39. In the year 1989, what is the difference between the Completion rate(% of total enrollments) of Netherlands and Completion rate(% of total enrollments) of United Arab Emirates?
Ensure brevity in your answer.  -1.08. In the year 1989, what is the difference between the Completion rate(% of total enrollments) in Togo and Completion rate(% of total enrollments) in United Arab Emirates?
Your answer should be compact. -48.47. In the year 1991, what is the difference between the Completion rate(% of total enrollments) of Mauritania and Completion rate(% of total enrollments) of Netherlands?
Your answer should be very brief. -50.56. In the year 1991, what is the difference between the Completion rate(% of total enrollments) of Mauritania and Completion rate(% of total enrollments) of Togo?
Offer a very short reply. -2.05. In the year 1991, what is the difference between the Completion rate(% of total enrollments) in Mauritania and Completion rate(% of total enrollments) in United Arab Emirates?
Give a very brief answer. -55.01. In the year 1991, what is the difference between the Completion rate(% of total enrollments) in Netherlands and Completion rate(% of total enrollments) in Togo?
Ensure brevity in your answer.  48.51. In the year 1991, what is the difference between the Completion rate(% of total enrollments) of Netherlands and Completion rate(% of total enrollments) of United Arab Emirates?
Make the answer very short. -4.45. In the year 1991, what is the difference between the Completion rate(% of total enrollments) of Togo and Completion rate(% of total enrollments) of United Arab Emirates?
Offer a very short reply. -52.96. In the year 1992, what is the difference between the Completion rate(% of total enrollments) of Mauritania and Completion rate(% of total enrollments) of Netherlands?
Ensure brevity in your answer.  -52.44. In the year 1992, what is the difference between the Completion rate(% of total enrollments) of Mauritania and Completion rate(% of total enrollments) of Togo?
Ensure brevity in your answer.  -2.52. In the year 1992, what is the difference between the Completion rate(% of total enrollments) of Mauritania and Completion rate(% of total enrollments) of United Arab Emirates?
Give a very brief answer. -58.36. In the year 1992, what is the difference between the Completion rate(% of total enrollments) of Netherlands and Completion rate(% of total enrollments) of Togo?
Offer a very short reply. 49.92. In the year 1992, what is the difference between the Completion rate(% of total enrollments) in Netherlands and Completion rate(% of total enrollments) in United Arab Emirates?
Give a very brief answer. -5.92. In the year 1992, what is the difference between the Completion rate(% of total enrollments) in Togo and Completion rate(% of total enrollments) in United Arab Emirates?
Your answer should be compact. -55.85. What is the ratio of the Completion rate(% of total enrollments) of Mauritania in 1983 to that in 1985?
Offer a terse response. 0.84. What is the ratio of the Completion rate(% of total enrollments) of Netherlands in 1983 to that in 1985?
Provide a succinct answer. 0.93. What is the ratio of the Completion rate(% of total enrollments) of Togo in 1983 to that in 1985?
Offer a very short reply. 1.51. What is the ratio of the Completion rate(% of total enrollments) of United Arab Emirates in 1983 to that in 1985?
Offer a very short reply. 0.95. What is the ratio of the Completion rate(% of total enrollments) in Mauritania in 1983 to that in 1986?
Offer a terse response. 0.89. What is the ratio of the Completion rate(% of total enrollments) of Netherlands in 1983 to that in 1986?
Make the answer very short. 0.93. What is the ratio of the Completion rate(% of total enrollments) in Togo in 1983 to that in 1986?
Keep it short and to the point. 1.57. What is the ratio of the Completion rate(% of total enrollments) in Mauritania in 1983 to that in 1987?
Make the answer very short. 0.82. What is the ratio of the Completion rate(% of total enrollments) of Netherlands in 1983 to that in 1987?
Offer a terse response. 0.94. What is the ratio of the Completion rate(% of total enrollments) of Togo in 1983 to that in 1987?
Provide a short and direct response. 1.56. What is the ratio of the Completion rate(% of total enrollments) in United Arab Emirates in 1983 to that in 1987?
Keep it short and to the point. 1.14. What is the ratio of the Completion rate(% of total enrollments) in Mauritania in 1983 to that in 1988?
Your answer should be compact. 0.8. What is the ratio of the Completion rate(% of total enrollments) in Netherlands in 1983 to that in 1988?
Offer a very short reply. 0.96. What is the ratio of the Completion rate(% of total enrollments) of Togo in 1983 to that in 1988?
Provide a short and direct response. 1.7. What is the ratio of the Completion rate(% of total enrollments) of United Arab Emirates in 1983 to that in 1988?
Your response must be concise. 1.18. What is the ratio of the Completion rate(% of total enrollments) of Mauritania in 1983 to that in 1989?
Your answer should be very brief. 0.89. What is the ratio of the Completion rate(% of total enrollments) in Netherlands in 1983 to that in 1989?
Provide a short and direct response. 0.98. What is the ratio of the Completion rate(% of total enrollments) of Togo in 1983 to that in 1989?
Your answer should be very brief. 1.51. What is the ratio of the Completion rate(% of total enrollments) in United Arab Emirates in 1983 to that in 1989?
Offer a very short reply. 1.1. What is the ratio of the Completion rate(% of total enrollments) in Mauritania in 1983 to that in 1991?
Keep it short and to the point. 0.95. What is the ratio of the Completion rate(% of total enrollments) of Netherlands in 1983 to that in 1991?
Keep it short and to the point. 0.95. What is the ratio of the Completion rate(% of total enrollments) in Togo in 1983 to that in 1991?
Offer a terse response. 1.4. What is the ratio of the Completion rate(% of total enrollments) of Mauritania in 1983 to that in 1992?
Ensure brevity in your answer.  0.91. What is the ratio of the Completion rate(% of total enrollments) in Netherlands in 1983 to that in 1992?
Make the answer very short. 0.91. What is the ratio of the Completion rate(% of total enrollments) in Togo in 1983 to that in 1992?
Your response must be concise. 1.31. What is the ratio of the Completion rate(% of total enrollments) in United Arab Emirates in 1983 to that in 1992?
Provide a short and direct response. 0.95. What is the ratio of the Completion rate(% of total enrollments) of Netherlands in 1985 to that in 1986?
Provide a succinct answer. 1. What is the ratio of the Completion rate(% of total enrollments) of Togo in 1985 to that in 1986?
Provide a short and direct response. 1.04. What is the ratio of the Completion rate(% of total enrollments) of United Arab Emirates in 1985 to that in 1986?
Your answer should be compact. 1.06. What is the ratio of the Completion rate(% of total enrollments) of Mauritania in 1985 to that in 1987?
Offer a terse response. 0.98. What is the ratio of the Completion rate(% of total enrollments) of Netherlands in 1985 to that in 1987?
Your answer should be very brief. 1.01. What is the ratio of the Completion rate(% of total enrollments) in Togo in 1985 to that in 1987?
Your response must be concise. 1.03. What is the ratio of the Completion rate(% of total enrollments) of United Arab Emirates in 1985 to that in 1987?
Offer a terse response. 1.2. What is the ratio of the Completion rate(% of total enrollments) in Mauritania in 1985 to that in 1988?
Your response must be concise. 0.95. What is the ratio of the Completion rate(% of total enrollments) of Netherlands in 1985 to that in 1988?
Your answer should be very brief. 1.03. What is the ratio of the Completion rate(% of total enrollments) of Togo in 1985 to that in 1988?
Your answer should be compact. 1.13. What is the ratio of the Completion rate(% of total enrollments) of United Arab Emirates in 1985 to that in 1988?
Give a very brief answer. 1.24. What is the ratio of the Completion rate(% of total enrollments) in Mauritania in 1985 to that in 1989?
Provide a short and direct response. 1.07. What is the ratio of the Completion rate(% of total enrollments) in Netherlands in 1985 to that in 1989?
Your response must be concise. 1.05. What is the ratio of the Completion rate(% of total enrollments) in United Arab Emirates in 1985 to that in 1989?
Keep it short and to the point. 1.15. What is the ratio of the Completion rate(% of total enrollments) in Mauritania in 1985 to that in 1991?
Keep it short and to the point. 1.14. What is the ratio of the Completion rate(% of total enrollments) in Netherlands in 1985 to that in 1991?
Give a very brief answer. 1.02. What is the ratio of the Completion rate(% of total enrollments) of Togo in 1985 to that in 1991?
Your answer should be compact. 0.93. What is the ratio of the Completion rate(% of total enrollments) in United Arab Emirates in 1985 to that in 1991?
Your answer should be very brief. 1.06. What is the ratio of the Completion rate(% of total enrollments) in Mauritania in 1985 to that in 1992?
Keep it short and to the point. 1.08. What is the ratio of the Completion rate(% of total enrollments) of Netherlands in 1985 to that in 1992?
Your answer should be very brief. 0.98. What is the ratio of the Completion rate(% of total enrollments) in Togo in 1985 to that in 1992?
Provide a succinct answer. 0.87. What is the ratio of the Completion rate(% of total enrollments) in Mauritania in 1986 to that in 1987?
Your response must be concise. 0.93. What is the ratio of the Completion rate(% of total enrollments) in Netherlands in 1986 to that in 1987?
Your answer should be very brief. 1.01. What is the ratio of the Completion rate(% of total enrollments) in United Arab Emirates in 1986 to that in 1987?
Provide a short and direct response. 1.13. What is the ratio of the Completion rate(% of total enrollments) in Mauritania in 1986 to that in 1988?
Give a very brief answer. 0.9. What is the ratio of the Completion rate(% of total enrollments) of Netherlands in 1986 to that in 1988?
Ensure brevity in your answer.  1.03. What is the ratio of the Completion rate(% of total enrollments) of Togo in 1986 to that in 1988?
Your answer should be very brief. 1.08. What is the ratio of the Completion rate(% of total enrollments) of United Arab Emirates in 1986 to that in 1988?
Keep it short and to the point. 1.17. What is the ratio of the Completion rate(% of total enrollments) in Mauritania in 1986 to that in 1989?
Provide a short and direct response. 1.01. What is the ratio of the Completion rate(% of total enrollments) of Netherlands in 1986 to that in 1989?
Your answer should be very brief. 1.05. What is the ratio of the Completion rate(% of total enrollments) in Togo in 1986 to that in 1989?
Provide a succinct answer. 0.96. What is the ratio of the Completion rate(% of total enrollments) of United Arab Emirates in 1986 to that in 1989?
Your answer should be compact. 1.09. What is the ratio of the Completion rate(% of total enrollments) in Mauritania in 1986 to that in 1991?
Offer a very short reply. 1.07. What is the ratio of the Completion rate(% of total enrollments) of Netherlands in 1986 to that in 1991?
Give a very brief answer. 1.02. What is the ratio of the Completion rate(% of total enrollments) in Togo in 1986 to that in 1991?
Provide a succinct answer. 0.89. What is the ratio of the Completion rate(% of total enrollments) of Netherlands in 1986 to that in 1992?
Your response must be concise. 0.98. What is the ratio of the Completion rate(% of total enrollments) of Togo in 1986 to that in 1992?
Provide a short and direct response. 0.83. What is the ratio of the Completion rate(% of total enrollments) in United Arab Emirates in 1986 to that in 1992?
Ensure brevity in your answer.  0.94. What is the ratio of the Completion rate(% of total enrollments) in Mauritania in 1987 to that in 1988?
Your answer should be compact. 0.97. What is the ratio of the Completion rate(% of total enrollments) in Netherlands in 1987 to that in 1988?
Provide a short and direct response. 1.02. What is the ratio of the Completion rate(% of total enrollments) of Togo in 1987 to that in 1988?
Give a very brief answer. 1.09. What is the ratio of the Completion rate(% of total enrollments) in United Arab Emirates in 1987 to that in 1988?
Keep it short and to the point. 1.03. What is the ratio of the Completion rate(% of total enrollments) of Mauritania in 1987 to that in 1989?
Offer a terse response. 1.09. What is the ratio of the Completion rate(% of total enrollments) of Netherlands in 1987 to that in 1989?
Provide a succinct answer. 1.04. What is the ratio of the Completion rate(% of total enrollments) in Togo in 1987 to that in 1989?
Your response must be concise. 0.97. What is the ratio of the Completion rate(% of total enrollments) of United Arab Emirates in 1987 to that in 1989?
Your answer should be compact. 0.96. What is the ratio of the Completion rate(% of total enrollments) of Mauritania in 1987 to that in 1991?
Your answer should be very brief. 1.15. What is the ratio of the Completion rate(% of total enrollments) in Togo in 1987 to that in 1991?
Give a very brief answer. 0.9. What is the ratio of the Completion rate(% of total enrollments) of United Arab Emirates in 1987 to that in 1991?
Offer a very short reply. 0.88. What is the ratio of the Completion rate(% of total enrollments) in Mauritania in 1987 to that in 1992?
Provide a succinct answer. 1.1. What is the ratio of the Completion rate(% of total enrollments) of Netherlands in 1987 to that in 1992?
Make the answer very short. 0.97. What is the ratio of the Completion rate(% of total enrollments) of Togo in 1987 to that in 1992?
Provide a short and direct response. 0.84. What is the ratio of the Completion rate(% of total enrollments) in United Arab Emirates in 1987 to that in 1992?
Make the answer very short. 0.83. What is the ratio of the Completion rate(% of total enrollments) in Mauritania in 1988 to that in 1989?
Offer a terse response. 1.12. What is the ratio of the Completion rate(% of total enrollments) of Netherlands in 1988 to that in 1989?
Your response must be concise. 1.02. What is the ratio of the Completion rate(% of total enrollments) of Togo in 1988 to that in 1989?
Ensure brevity in your answer.  0.89. What is the ratio of the Completion rate(% of total enrollments) of United Arab Emirates in 1988 to that in 1989?
Provide a succinct answer. 0.93. What is the ratio of the Completion rate(% of total enrollments) of Mauritania in 1988 to that in 1991?
Keep it short and to the point. 1.19. What is the ratio of the Completion rate(% of total enrollments) of Netherlands in 1988 to that in 1991?
Offer a very short reply. 0.99. What is the ratio of the Completion rate(% of total enrollments) in Togo in 1988 to that in 1991?
Your answer should be very brief. 0.83. What is the ratio of the Completion rate(% of total enrollments) in United Arab Emirates in 1988 to that in 1991?
Offer a terse response. 0.85. What is the ratio of the Completion rate(% of total enrollments) of Mauritania in 1988 to that in 1992?
Offer a terse response. 1.14. What is the ratio of the Completion rate(% of total enrollments) in Netherlands in 1988 to that in 1992?
Offer a terse response. 0.95. What is the ratio of the Completion rate(% of total enrollments) in Togo in 1988 to that in 1992?
Offer a very short reply. 0.77. What is the ratio of the Completion rate(% of total enrollments) of United Arab Emirates in 1988 to that in 1992?
Your answer should be compact. 0.81. What is the ratio of the Completion rate(% of total enrollments) of Mauritania in 1989 to that in 1991?
Ensure brevity in your answer.  1.06. What is the ratio of the Completion rate(% of total enrollments) in Netherlands in 1989 to that in 1991?
Ensure brevity in your answer.  0.97. What is the ratio of the Completion rate(% of total enrollments) in Togo in 1989 to that in 1991?
Provide a succinct answer. 0.93. What is the ratio of the Completion rate(% of total enrollments) in United Arab Emirates in 1989 to that in 1991?
Give a very brief answer. 0.92. What is the ratio of the Completion rate(% of total enrollments) in Mauritania in 1989 to that in 1992?
Provide a succinct answer. 1.01. What is the ratio of the Completion rate(% of total enrollments) in Netherlands in 1989 to that in 1992?
Give a very brief answer. 0.93. What is the ratio of the Completion rate(% of total enrollments) in Togo in 1989 to that in 1992?
Offer a terse response. 0.86. What is the ratio of the Completion rate(% of total enrollments) of United Arab Emirates in 1989 to that in 1992?
Offer a terse response. 0.87. What is the ratio of the Completion rate(% of total enrollments) of Mauritania in 1991 to that in 1992?
Your answer should be very brief. 0.96. What is the ratio of the Completion rate(% of total enrollments) of Netherlands in 1991 to that in 1992?
Give a very brief answer. 0.96. What is the ratio of the Completion rate(% of total enrollments) of Togo in 1991 to that in 1992?
Keep it short and to the point. 0.93. What is the ratio of the Completion rate(% of total enrollments) of United Arab Emirates in 1991 to that in 1992?
Offer a very short reply. 0.94. What is the difference between the highest and the second highest Completion rate(% of total enrollments) of Mauritania?
Give a very brief answer. 0.39. What is the difference between the highest and the second highest Completion rate(% of total enrollments) of Netherlands?
Provide a succinct answer. 1.3. What is the difference between the highest and the second highest Completion rate(% of total enrollments) in Togo?
Offer a very short reply. 4.32. What is the difference between the highest and the second highest Completion rate(% of total enrollments) of United Arab Emirates?
Your response must be concise. 0.02. What is the difference between the highest and the lowest Completion rate(% of total enrollments) in Mauritania?
Provide a short and direct response. 2.68. What is the difference between the highest and the lowest Completion rate(% of total enrollments) of Netherlands?
Offer a terse response. 5.45. What is the difference between the highest and the lowest Completion rate(% of total enrollments) of Togo?
Your answer should be compact. 7.59. What is the difference between the highest and the lowest Completion rate(% of total enrollments) in United Arab Emirates?
Offer a terse response. 13.5. 